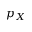<formula> <loc_0><loc_0><loc_500><loc_500>p _ { X }</formula> 